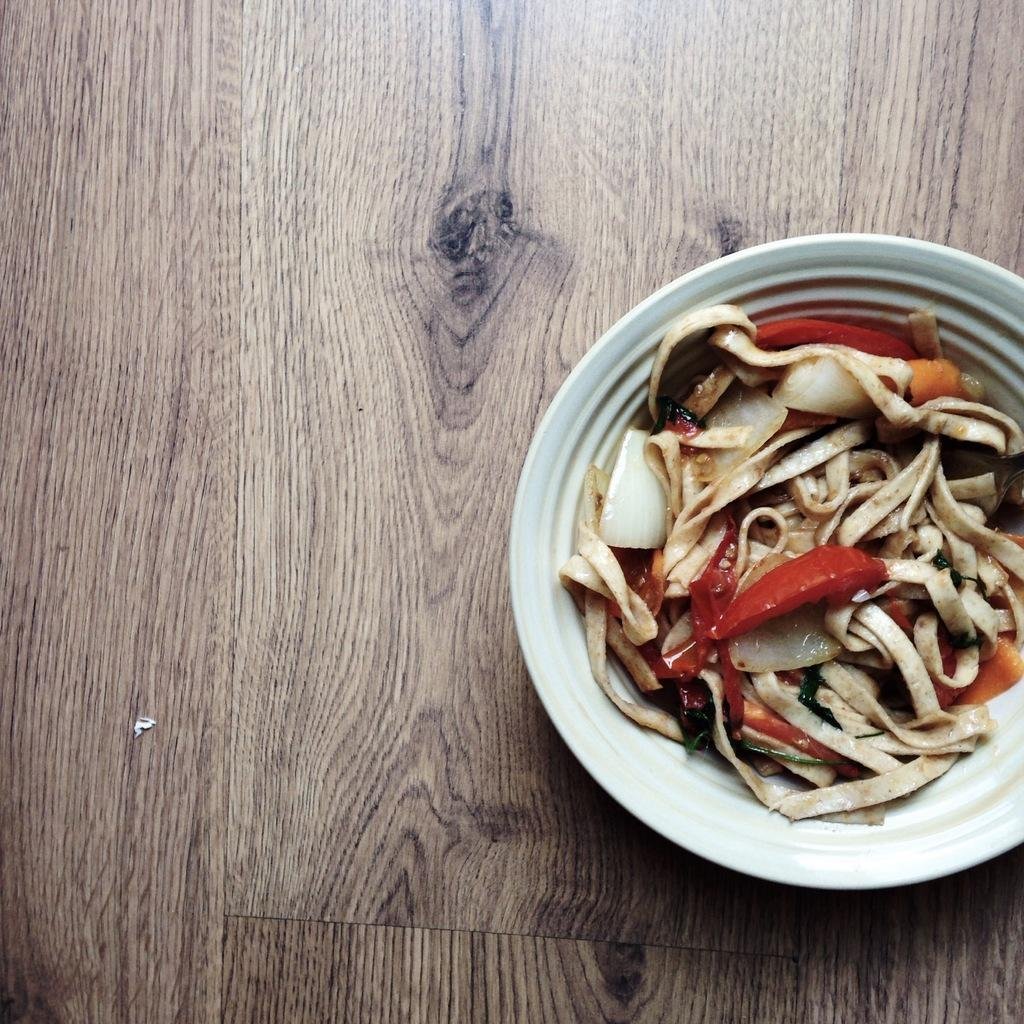What type of furniture is present in the image? There is a table in the image. Where is the bowl with food located in relation to the table? The bowl with food is on the right side of the table. Where is the faucet located in the image? There is no faucet present in the image. What type of birthday celebration is taking place in the image? There is no indication of a birthday celebration in the image. 